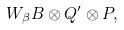<formula> <loc_0><loc_0><loc_500><loc_500>W _ { \beta } B \otimes Q ^ { \prime } \otimes P ,</formula> 